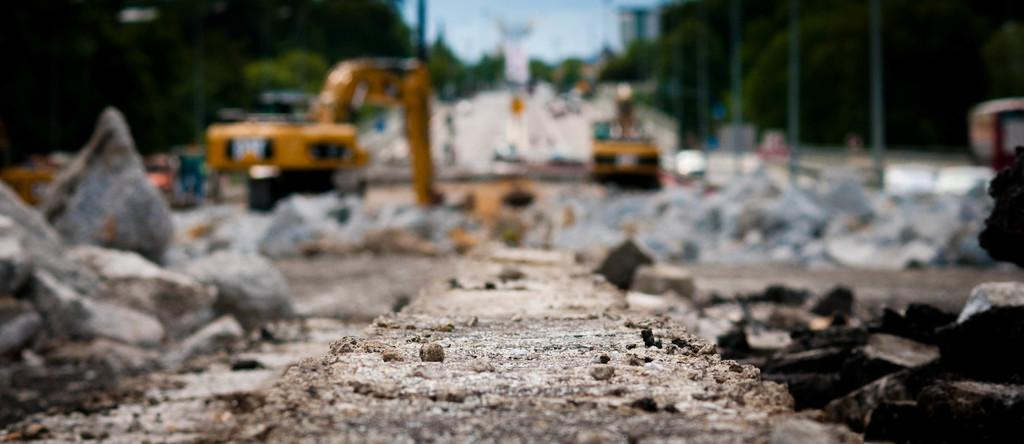What type of terrain is visible in the image? There is land visible in the image. What can be seen in the background of the image? There are rocks, cranes, greenery, poles, and the sky visible in the background of the image. What type of vegetable is growing on the fan in the image? There is no fan or vegetable present in the image. 